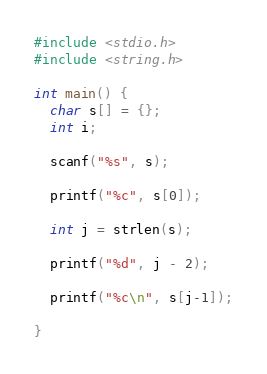<code> <loc_0><loc_0><loc_500><loc_500><_C_>#include <stdio.h>
#include <string.h>

int main() {
  char s[] = {};
  int i;

  scanf("%s", s);

  printf("%c", s[0]);

  int j = strlen(s);

  printf("%d", j - 2);

  printf("%c\n", s[j-1]);

}
</code> 